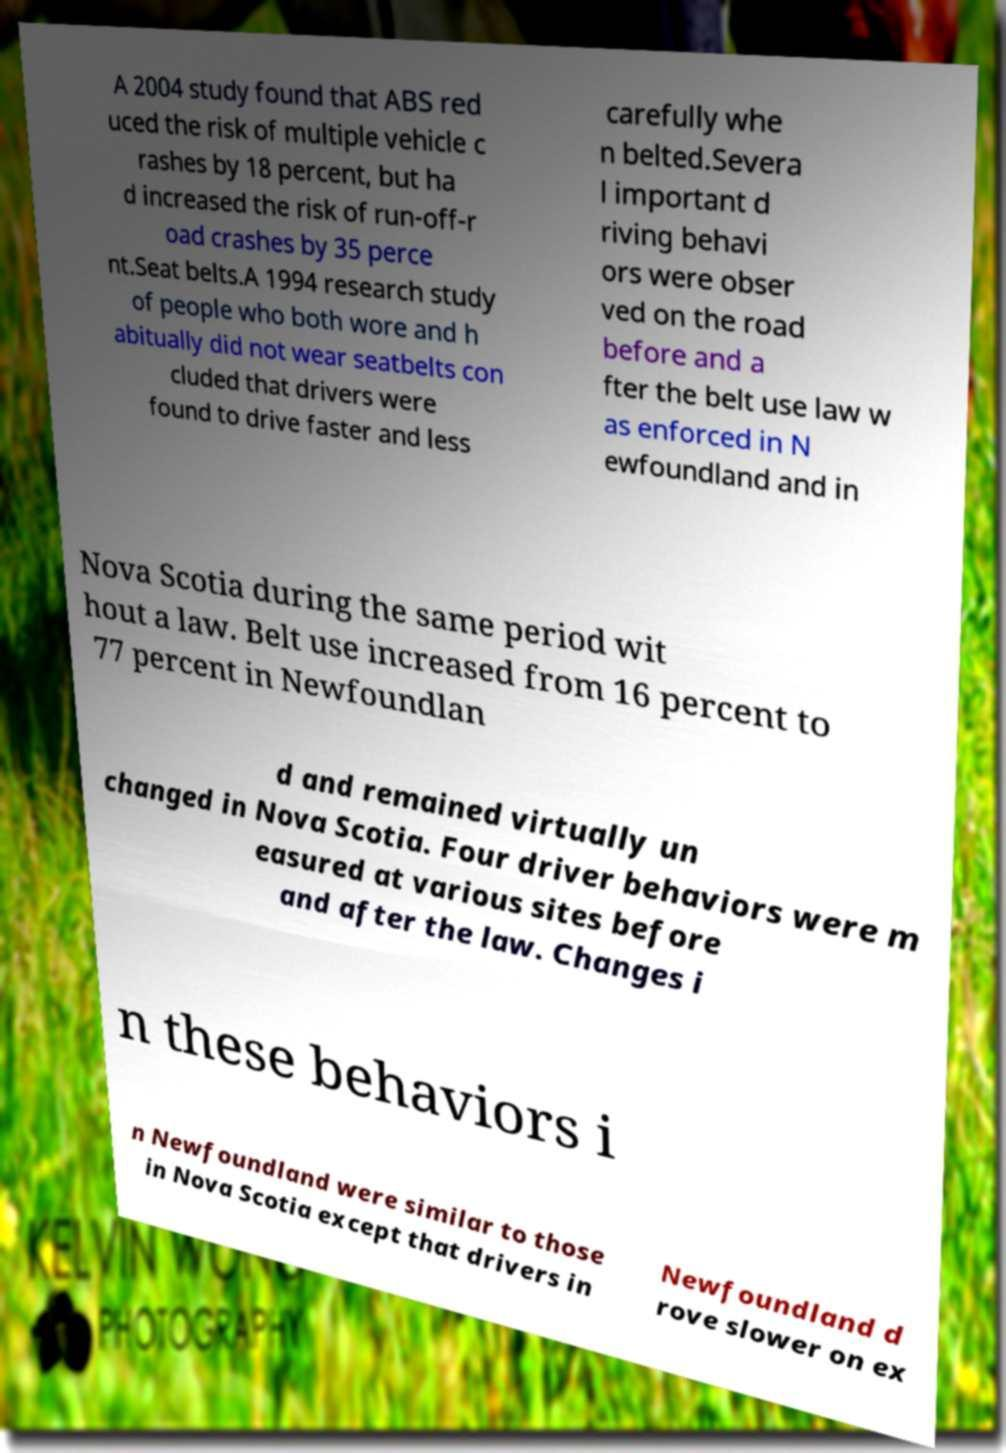Please read and relay the text visible in this image. What does it say? A 2004 study found that ABS red uced the risk of multiple vehicle c rashes by 18 percent, but ha d increased the risk of run-off-r oad crashes by 35 perce nt.Seat belts.A 1994 research study of people who both wore and h abitually did not wear seatbelts con cluded that drivers were found to drive faster and less carefully whe n belted.Severa l important d riving behavi ors were obser ved on the road before and a fter the belt use law w as enforced in N ewfoundland and in Nova Scotia during the same period wit hout a law. Belt use increased from 16 percent to 77 percent in Newfoundlan d and remained virtually un changed in Nova Scotia. Four driver behaviors were m easured at various sites before and after the law. Changes i n these behaviors i n Newfoundland were similar to those in Nova Scotia except that drivers in Newfoundland d rove slower on ex 